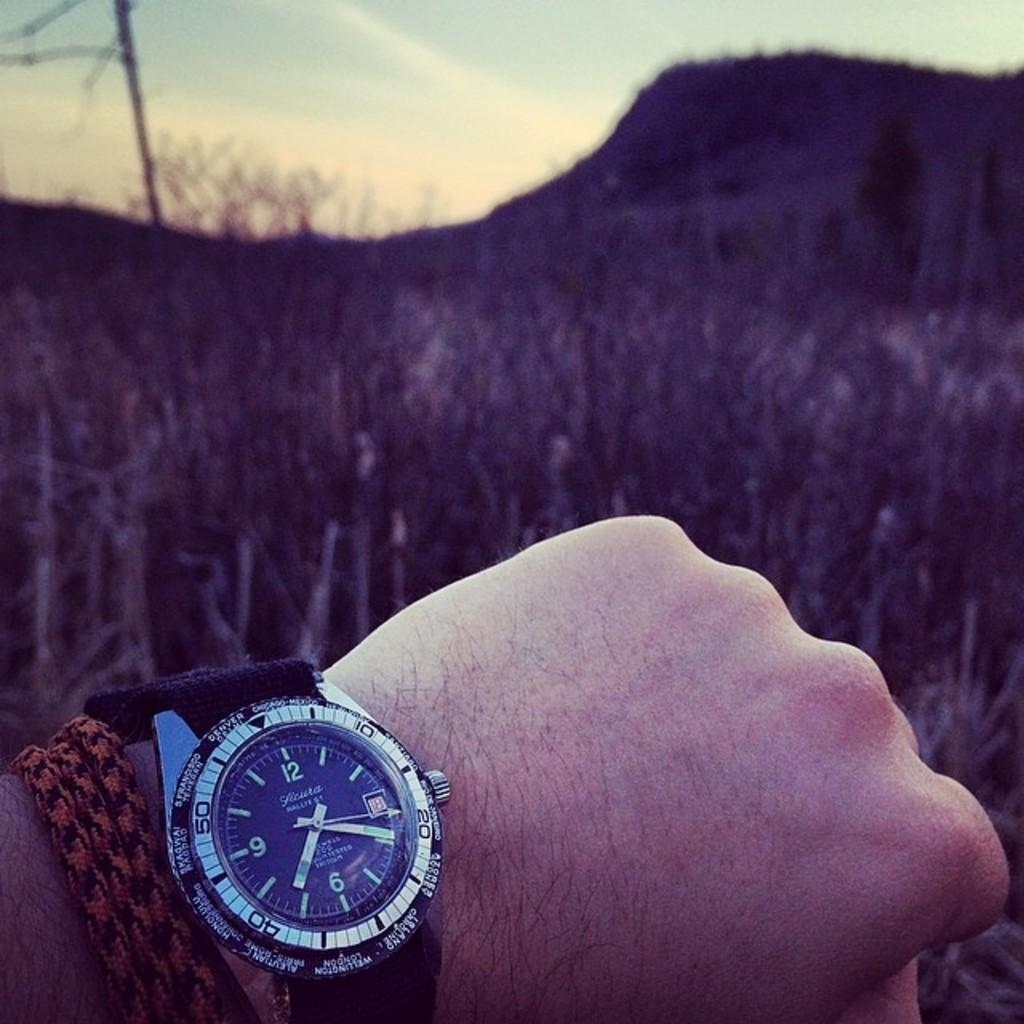<image>
Describe the image concisely. A hand with a watch can be seen in front of a field with the second arrow pointing to the number 20 